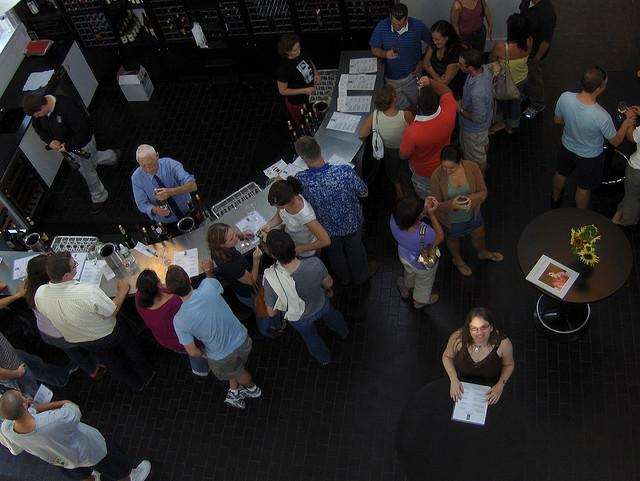What are most people gathered around? Please explain your reasoning. bar. There is a setup that resembles a bar based on the height of the table and most visible people are standing and leaning around it. there are also people inside who appear to be preparing drinks as one would do at a bar. 